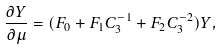<formula> <loc_0><loc_0><loc_500><loc_500>\frac { \partial Y } { \partial \mu } = ( F _ { 0 } + F _ { 1 } C _ { 3 } ^ { - 1 } + F _ { 2 } C _ { 3 } ^ { - 2 } ) Y ,</formula> 